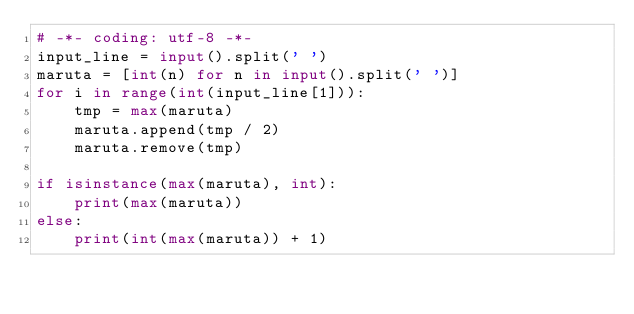<code> <loc_0><loc_0><loc_500><loc_500><_Python_># -*- coding: utf-8 -*-
input_line = input().split(' ')
maruta = [int(n) for n in input().split(' ')]
for i in range(int(input_line[1])):
    tmp = max(maruta)
    maruta.append(tmp / 2)
    maruta.remove(tmp)

if isinstance(max(maruta), int):
    print(max(maruta))
else:
    print(int(max(maruta)) + 1)</code> 